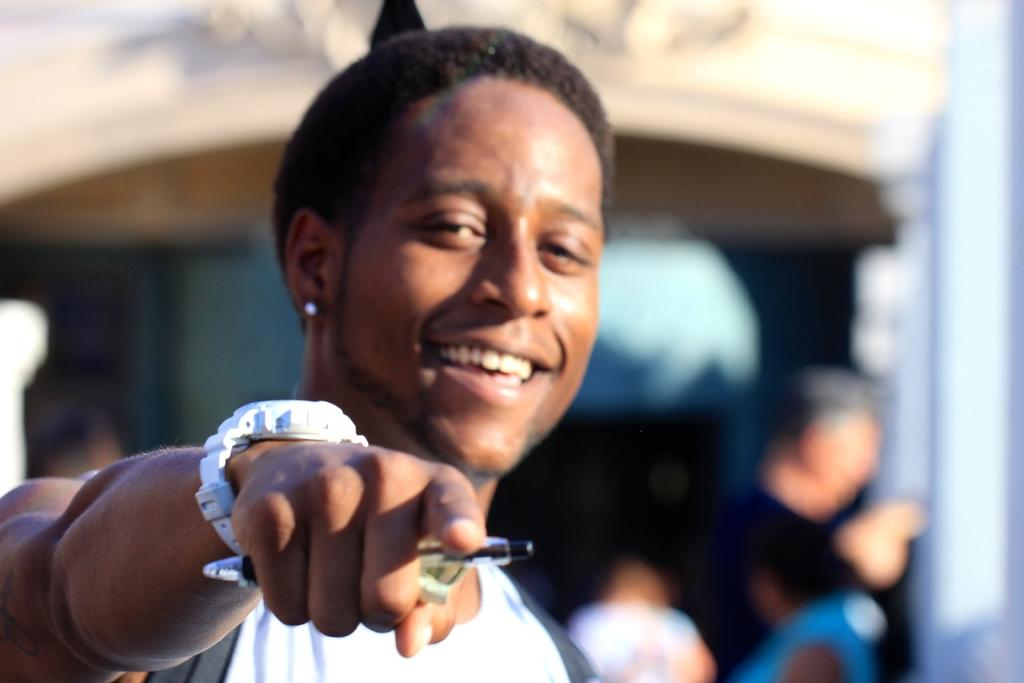Who is present in the image? There is a man in the image. What is the man wearing on his wrist? The man is wearing a watch. What is the man holding in his hand? The man is holding an object in his hand. Can you describe the background of the image? The background of the image is blurred. What type of coast can be seen in the background of the image? There is no coast visible in the image; the background is blurred. What advice would the coach give to the man in the image? There is no coach present in the image, so it is not possible to determine what advice they might give. 